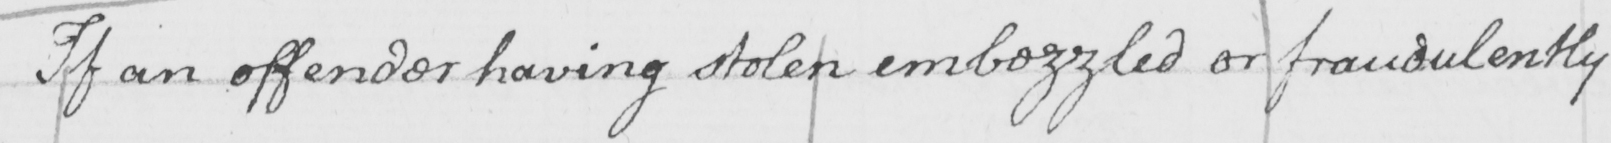Please provide the text content of this handwritten line. If an offender having stolen embezzled or fraudulently 